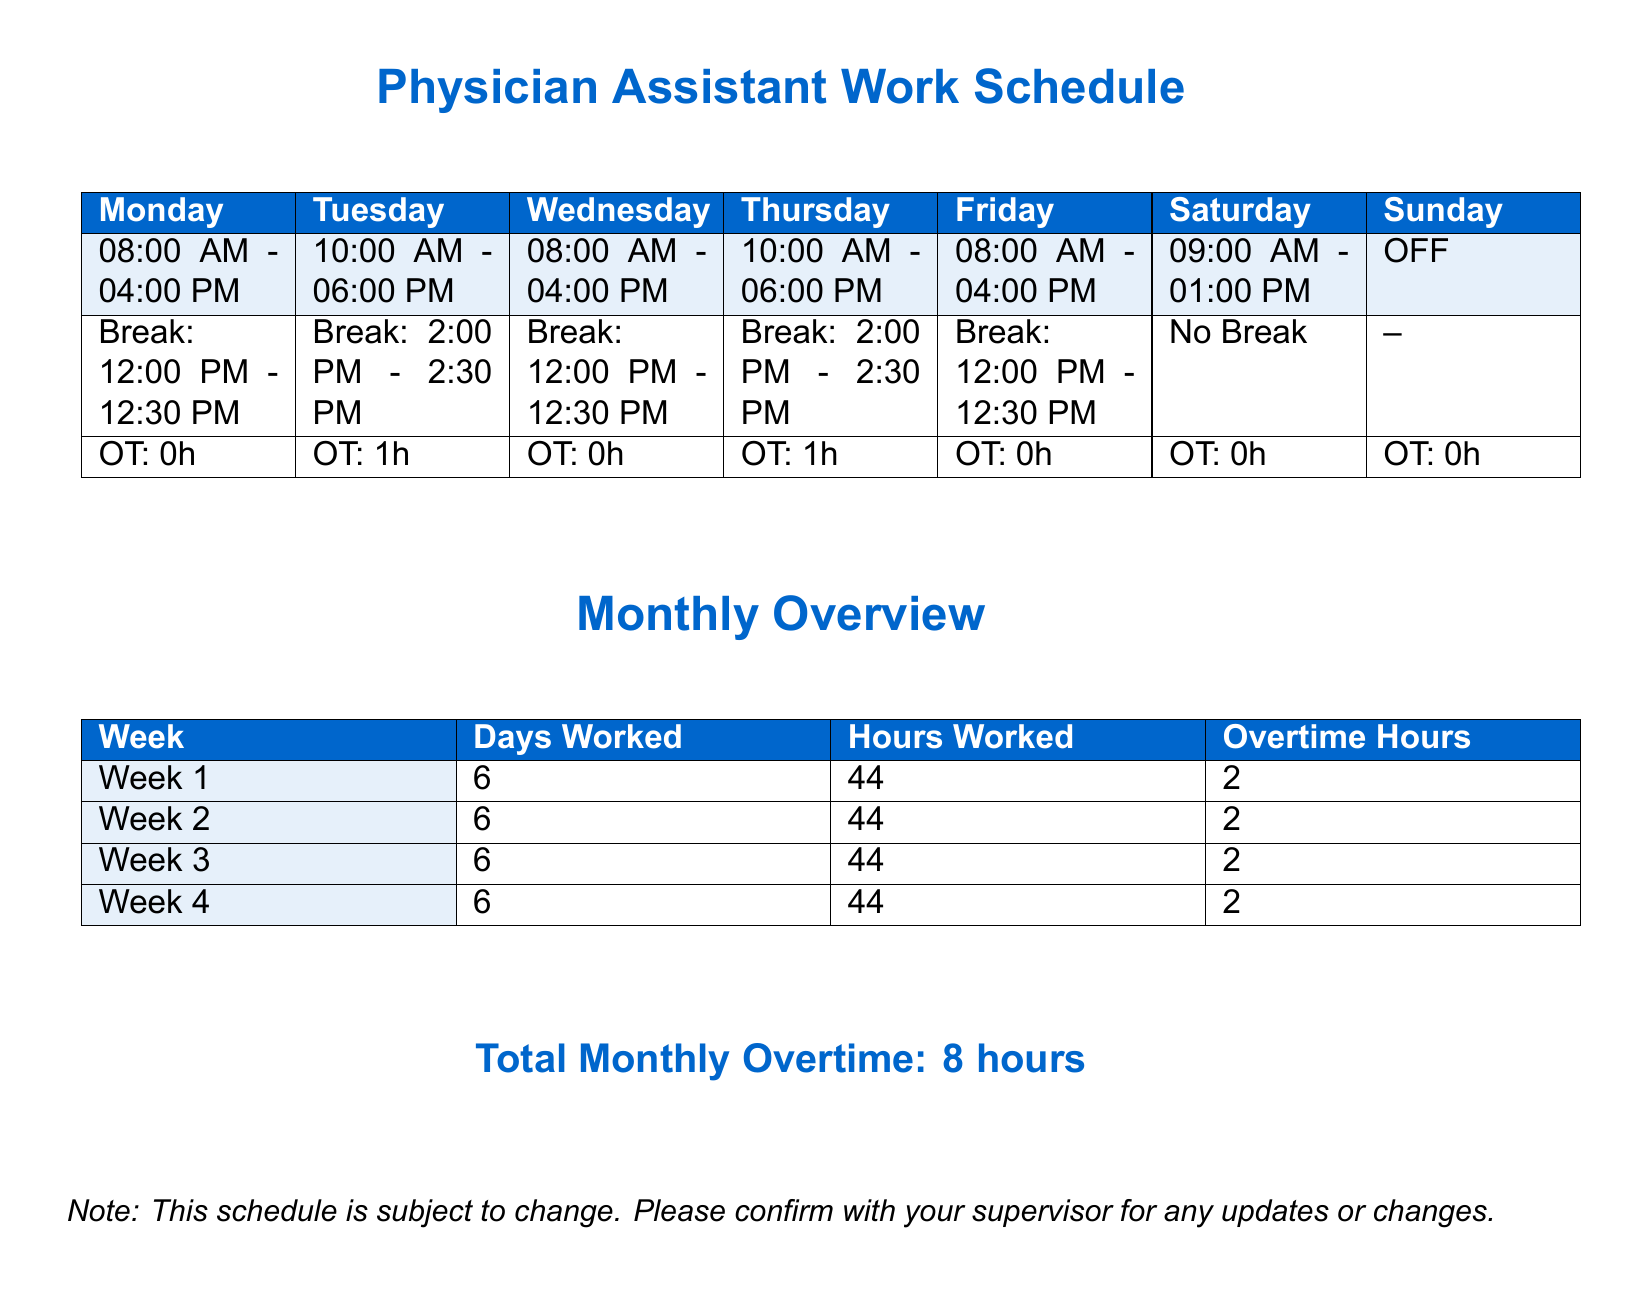What is the total monthly overtime? The total monthly overtime is provided at the end of the document in a summary, quantifying the extra work hours over the regular schedule.
Answer: 8 hours What is the break time on Wednesday? The break time for Wednesday is included in the daily schedule section, detailing the specific hour when the break occurs.
Answer: 12:00 PM - 12:30 PM How many hours did the PA work in Week 2? The hours worked are listed weekly in the monthly overview table, detailing work hours for each week.
Answer: 44 What day is marked as OFF? The weekly schedule presents each day's activity and identifies when the PA is not scheduled to work.
Answer: Sunday How many days did the PA work in total for the month? The monthly overview table provides the number of days worked each week, which can be summed up to find the total.
Answer: 24 